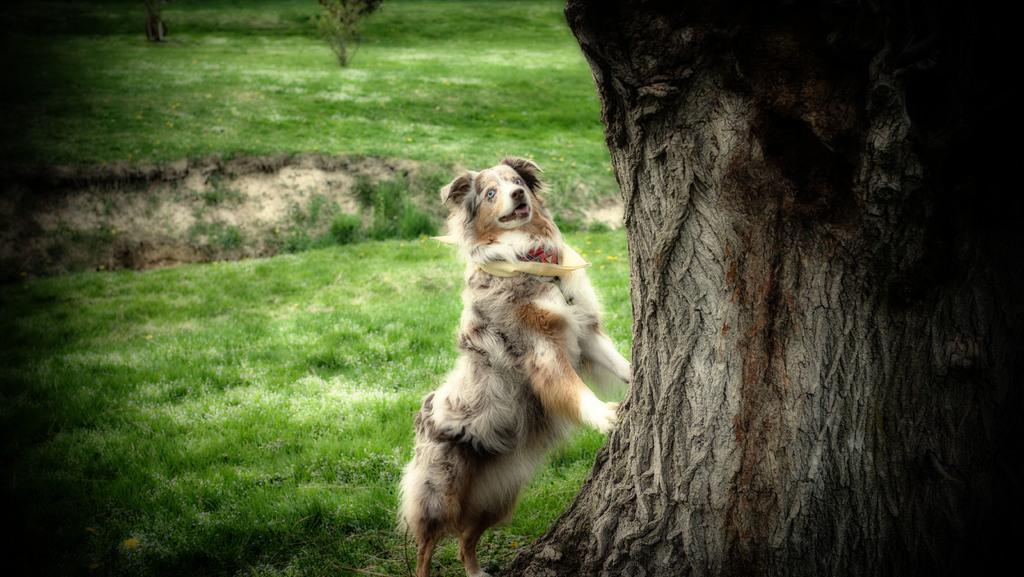Can you describe this image briefly? In this image I can see a dog is trying to climb the tree. In the middle there is the grass. 